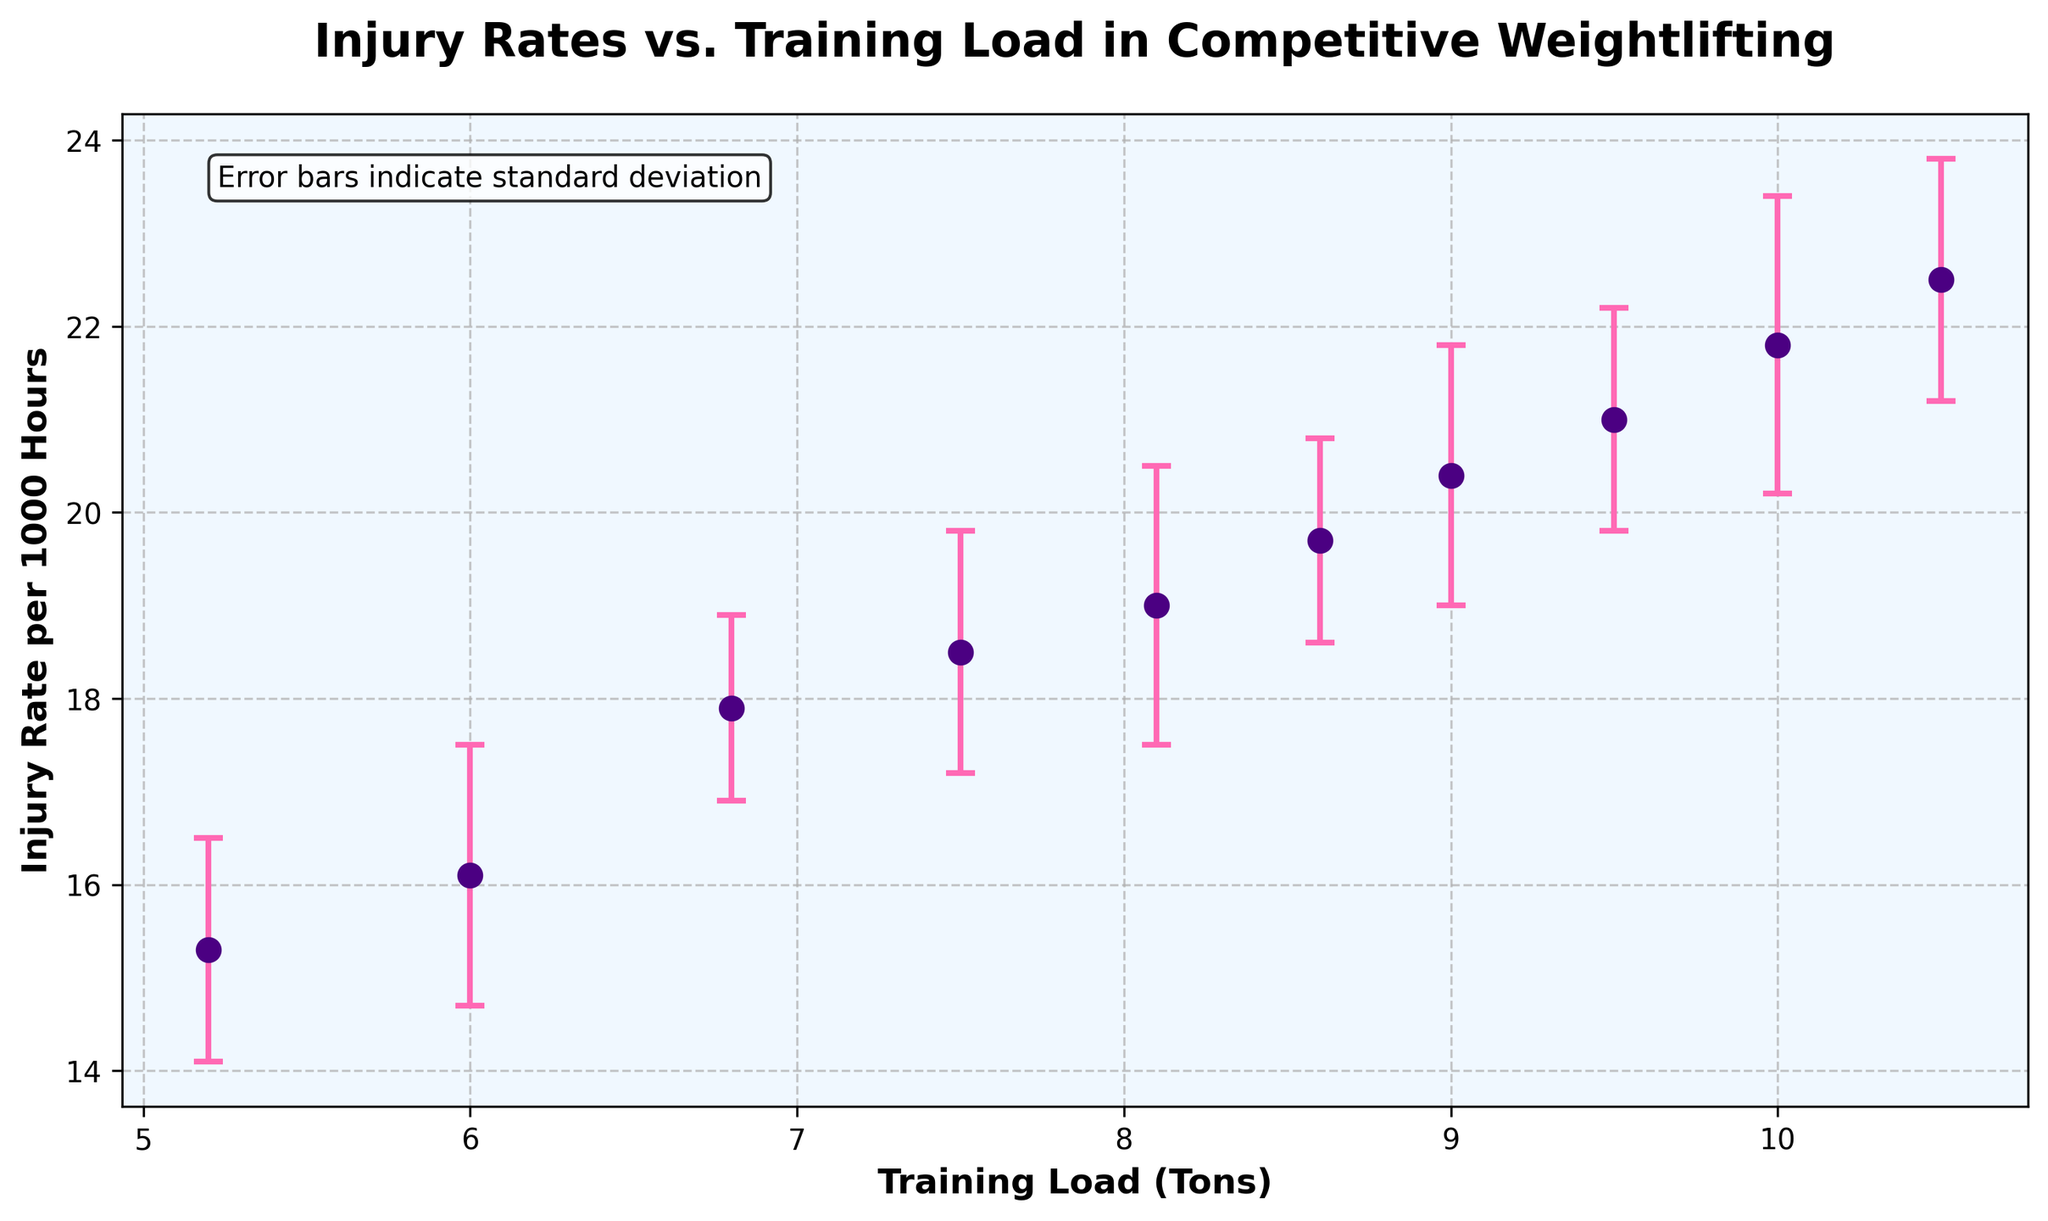What's the title of the figure? The title of the figure is located at the top and reads: "Injury Rates vs. Training Load in Competitive Weightlifting".
Answer: Injury Rates vs. Training Load in Competitive Weightlifting What are the axes labels? The x-axis label is "Training Load (Tons)" and the y-axis label is "Injury Rate per 1000 Hours".
Answer: Training Load (Tons) and Injury Rate per 1000 Hours How many data points are plotted in the figure? By counting the markers (dots) in the scatter plot, we can see there are 10 data points.
Answer: 10 At which training load does the injury rate first surpass 20 injuries per 1000 hours? Observing the y-axis values where it surpasses 20 injuries and checking the corresponding x-axis value, it first passes 20 at the training load of 9.0 tons.
Answer: 9.0 tons What color are the error bars? The error bars are colored pink.
Answer: pink What is the injury rate at 8.1 tons training load and its standard deviation? By finding 8.1 on the x-axis and locating the corresponding y-axis value, we see the injury rate is 19.0 per 1000 hours with a standard deviation of 1.5.
Answer: 19.0 injuries per 1000 hours and standard deviation of 1.5 What's the difference in injury rate between the highest and lowest training loads? The highest training load has an injury rate of 22.5, while the lowest has an injury rate of 15.3. The difference is 22.5 - 15.3 = 7.2.
Answer: 7.2 Which training cycle had the highest injury rate? Observing the plot, the highest point on the y-axis corresponds to the training load of 10.5 tons which is Cycle 10.
Answer: Cycle 10 Does the training load generally have a positive or negative correlation with the injury rate? By observing the upward trend in the plot, as training load increases, injury rates also increase. This indicates a positive correlation.
Answer: Positive Are there any data points with the same injury rate but different training loads? By inspecting the y-values, no two data points share the exact same injury rate.
Answer: No 